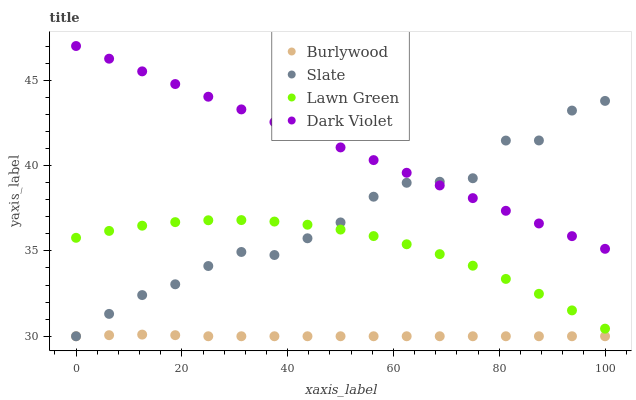Does Burlywood have the minimum area under the curve?
Answer yes or no. Yes. Does Dark Violet have the maximum area under the curve?
Answer yes or no. Yes. Does Lawn Green have the minimum area under the curve?
Answer yes or no. No. Does Lawn Green have the maximum area under the curve?
Answer yes or no. No. Is Dark Violet the smoothest?
Answer yes or no. Yes. Is Slate the roughest?
Answer yes or no. Yes. Is Lawn Green the smoothest?
Answer yes or no. No. Is Lawn Green the roughest?
Answer yes or no. No. Does Burlywood have the lowest value?
Answer yes or no. Yes. Does Lawn Green have the lowest value?
Answer yes or no. No. Does Dark Violet have the highest value?
Answer yes or no. Yes. Does Lawn Green have the highest value?
Answer yes or no. No. Is Burlywood less than Lawn Green?
Answer yes or no. Yes. Is Dark Violet greater than Lawn Green?
Answer yes or no. Yes. Does Slate intersect Burlywood?
Answer yes or no. Yes. Is Slate less than Burlywood?
Answer yes or no. No. Is Slate greater than Burlywood?
Answer yes or no. No. Does Burlywood intersect Lawn Green?
Answer yes or no. No. 